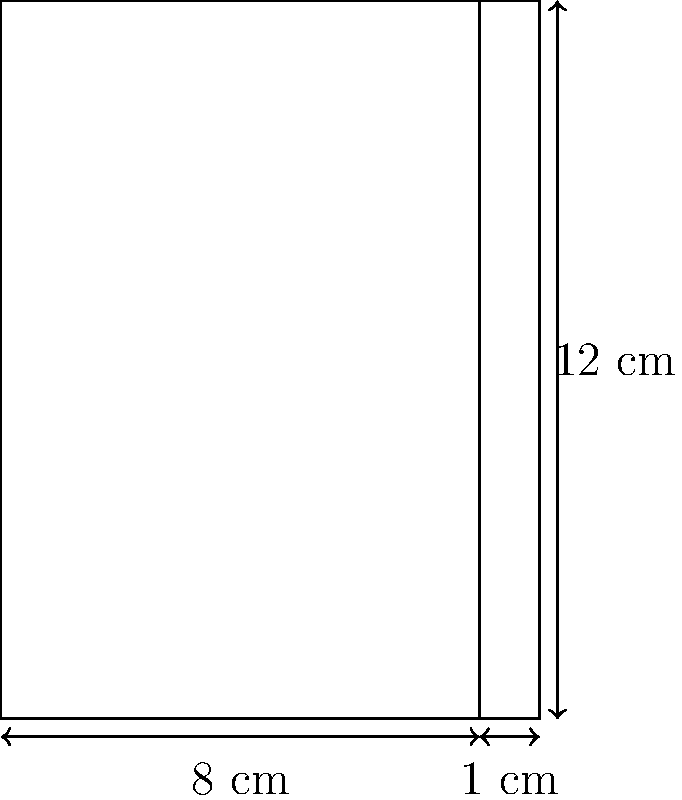As a librarian specializing in medieval literature, you've come across a historical fiction novel about Catherine of Aragon. The book's dimensions are 8 cm wide, 12 cm tall, and 1 cm thick. Assuming the paper used is similar to modern paper with a thickness of 0.1 mm, estimate the number of pages in this book. Round your answer to the nearest whole number. Let's approach this step-by-step:

1) First, we need to convert the book's thickness from centimeters to millimeters:
   $1 \text{ cm} = 10 \text{ mm}$

2) Now, we know that each page has a thickness of 0.1 mm. To find the number of pages, we need to divide the total thickness by the thickness of one page:

   $\text{Number of pages} = \frac{\text{Total thickness}}{\text{Thickness of one page}}$

3) Substituting our values:

   $\text{Number of pages} = \frac{10 \text{ mm}}{0.1 \text{ mm/page}}$

4) Simplifying:

   $\text{Number of pages} = 100 \text{ pages}$

5) However, we need to account for the front and back covers. Assuming each cover is approximately as thick as 5 pages:

   $\text{Total pages} = 100 - (2 \times 5) = 90 \text{ pages}$

6) Since a book typically has content on both sides of a page, we multiply by 2:

   $\text{Total printed pages} = 90 \times 2 = 180 \text{ pages}$

Therefore, we estimate that this medieval-style book about Catherine of Aragon contains approximately 180 printed pages.
Answer: 180 pages 